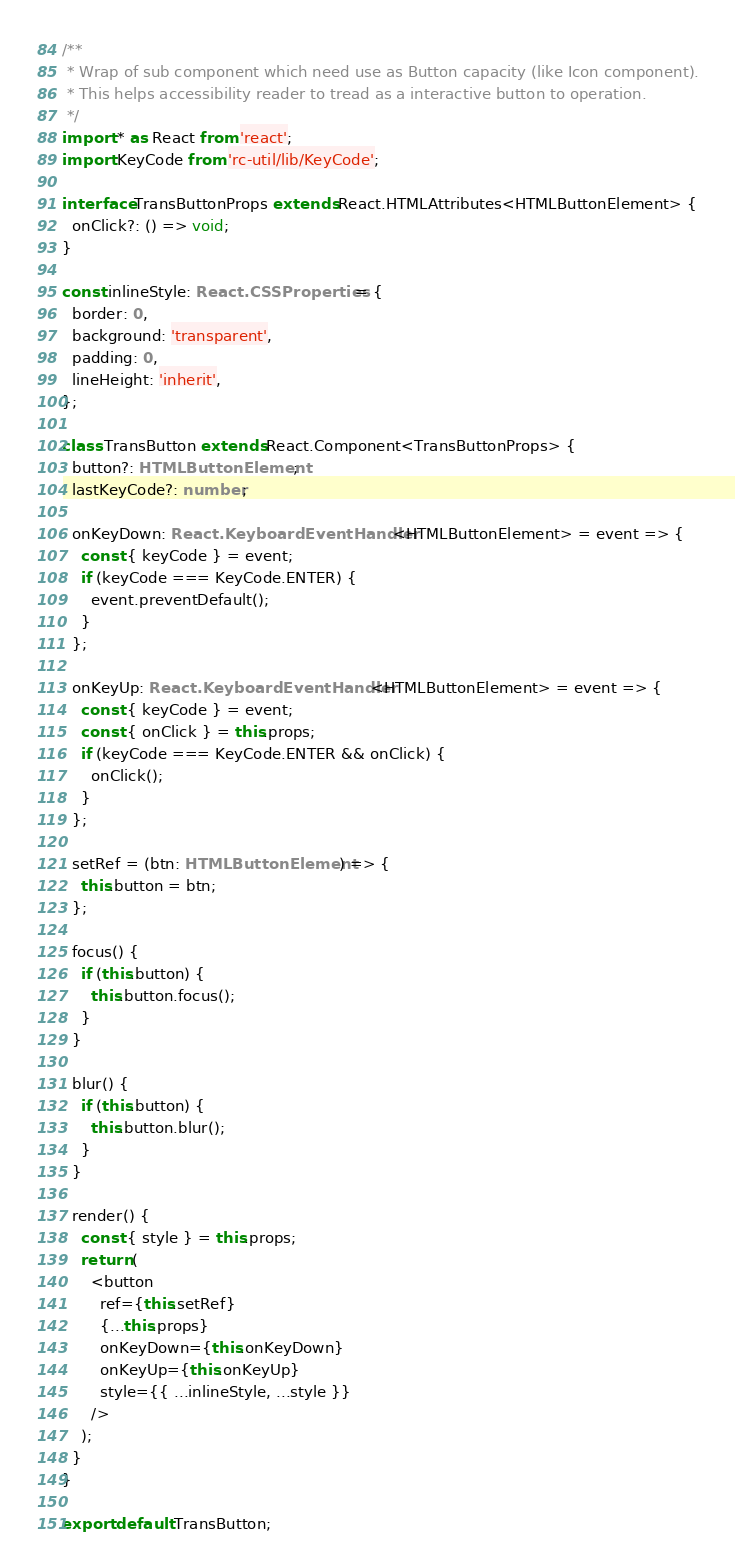Convert code to text. <code><loc_0><loc_0><loc_500><loc_500><_TypeScript_>/**
 * Wrap of sub component which need use as Button capacity (like Icon component).
 * This helps accessibility reader to tread as a interactive button to operation.
 */
import * as React from 'react';
import KeyCode from 'rc-util/lib/KeyCode';

interface TransButtonProps extends React.HTMLAttributes<HTMLButtonElement> {
  onClick?: () => void;
}

const inlineStyle: React.CSSProperties = {
  border: 0,
  background: 'transparent',
  padding: 0,
  lineHeight: 'inherit',
};

class TransButton extends React.Component<TransButtonProps> {
  button?: HTMLButtonElement;
  lastKeyCode?: number;

  onKeyDown: React.KeyboardEventHandler<HTMLButtonElement> = event => {
    const { keyCode } = event;
    if (keyCode === KeyCode.ENTER) {
      event.preventDefault();
    }
  };

  onKeyUp: React.KeyboardEventHandler<HTMLButtonElement> = event => {
    const { keyCode } = event;
    const { onClick } = this.props;
    if (keyCode === KeyCode.ENTER && onClick) {
      onClick();
    }
  };

  setRef = (btn: HTMLButtonElement) => {
    this.button = btn;
  };

  focus() {
    if (this.button) {
      this.button.focus();
    }
  }

  blur() {
    if (this.button) {
      this.button.blur();
    }
  }

  render() {
    const { style } = this.props;
    return (
      <button
        ref={this.setRef}
        {...this.props}
        onKeyDown={this.onKeyDown}
        onKeyUp={this.onKeyUp}
        style={{ ...inlineStyle, ...style }}
      />
    );
  }
}

export default TransButton;
</code> 